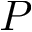Convert formula to latex. <formula><loc_0><loc_0><loc_500><loc_500>P</formula> 